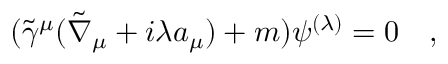Convert formula to latex. <formula><loc_0><loc_0><loc_500><loc_500>( \tilde { \gamma } ^ { \mu } ( \tilde { \nabla } _ { \mu } + i \lambda a _ { \mu } ) + m ) \psi ^ { ( \lambda ) } = 0 ,</formula> 